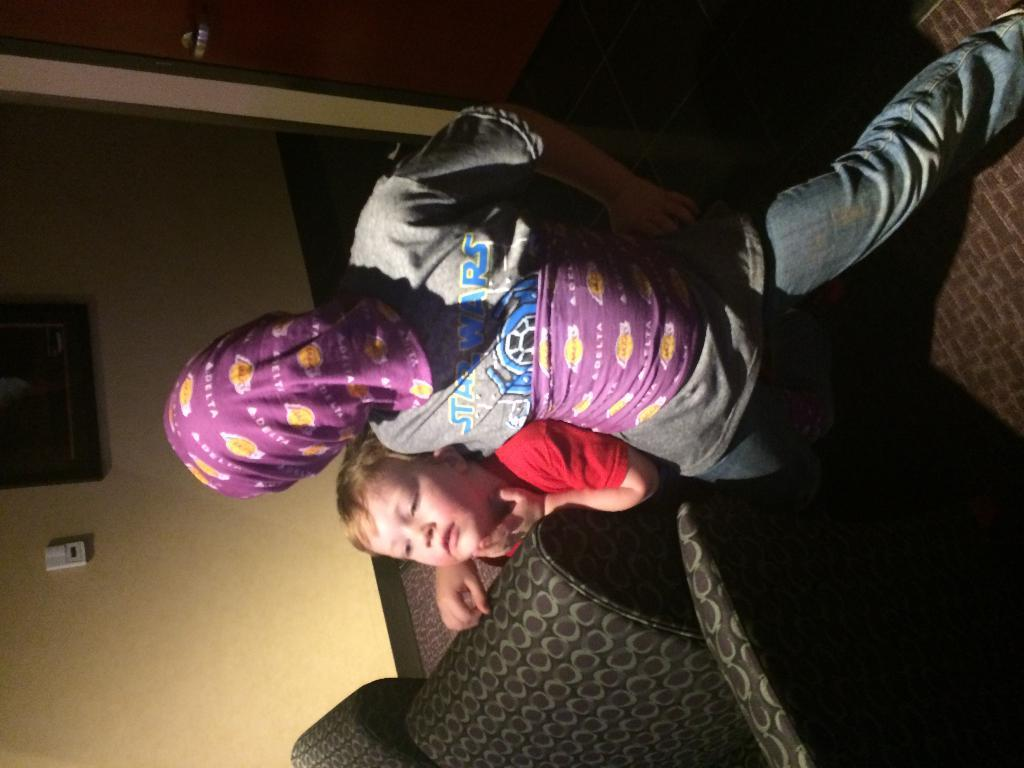What type of furniture is present in the image? There is a sofa in the image. Who is present in the image? There is a boy and another person in the image. What can be seen in the background of the image? There is a wall in the background of the image. What type of sea creature is visible on the sofa in the image? There is no sea creature visible on the sofa in the image. What is the boy using to write on the wall in the image? There is no quill or writing activity depicted in the image. 